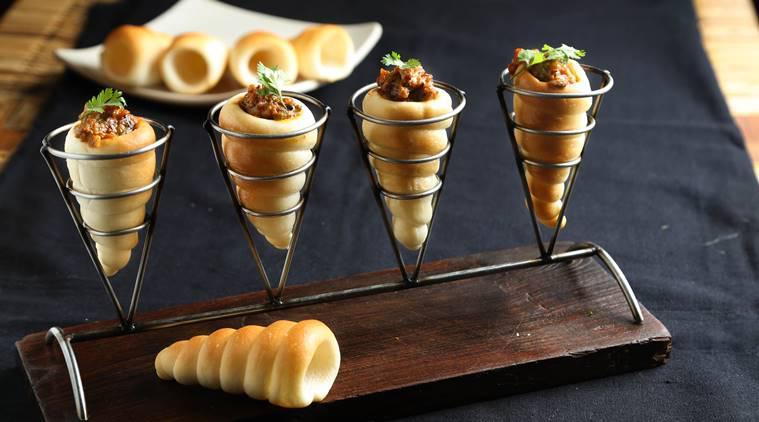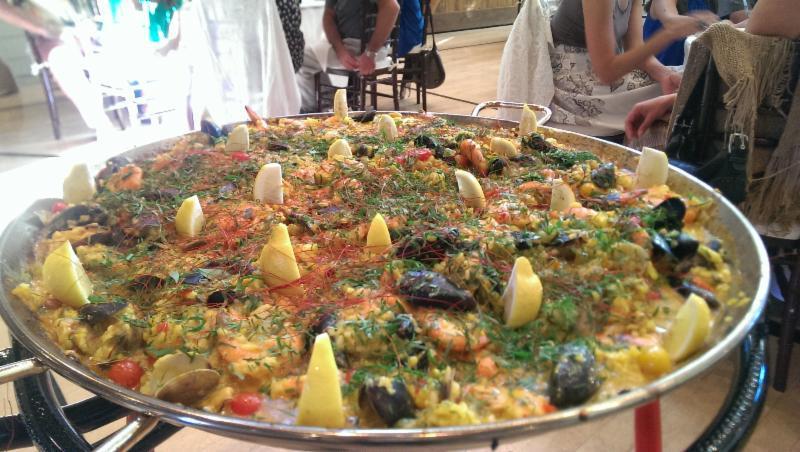The first image is the image on the left, the second image is the image on the right. Evaluate the accuracy of this statement regarding the images: "The left image includes a man wearing black on top standing in front of a counter, and a white tray containing food.". Is it true? Answer yes or no. No. The first image is the image on the left, the second image is the image on the right. Given the left and right images, does the statement "There are customers sitting." hold true? Answer yes or no. Yes. 